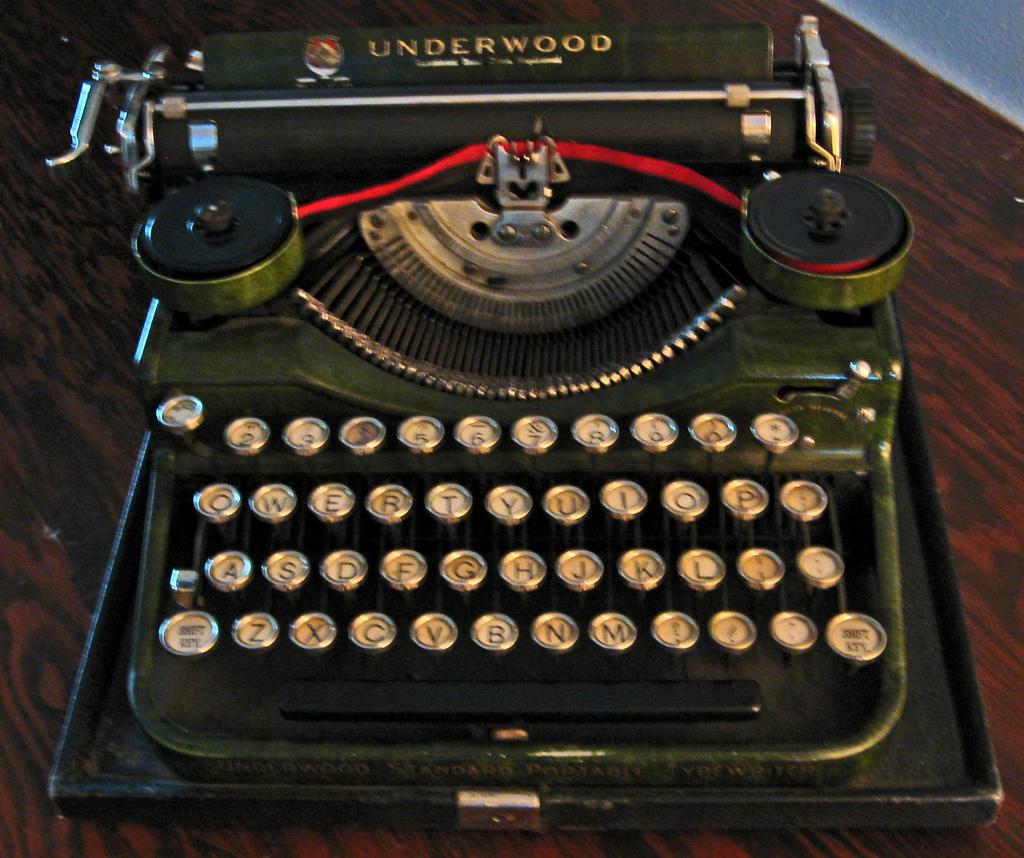What kind of typewriter is this?
Your response must be concise. Underwood. Is the letter q found on this typewriter?
Your answer should be compact. Yes. 